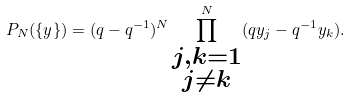<formula> <loc_0><loc_0><loc_500><loc_500>P _ { N } ( \{ y \} ) = ( q - q ^ { - 1 } ) ^ { N } \prod _ { \substack { j , k = 1 \\ j \neq k } } ^ { N } ( q y _ { j } - q ^ { - 1 } y _ { k } ) .</formula> 